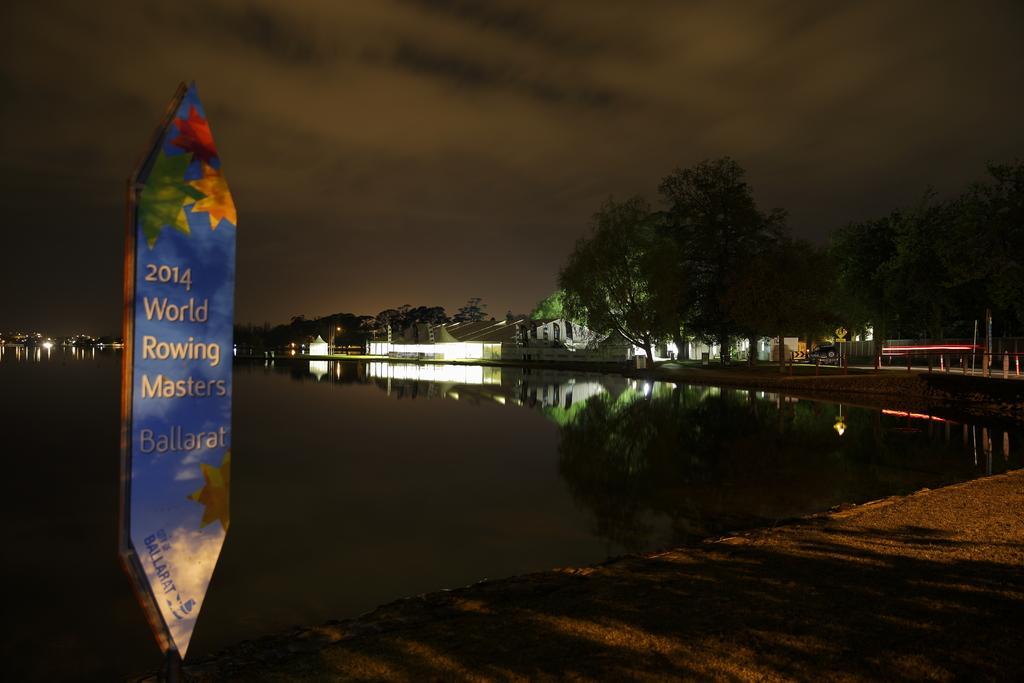In one or two sentences, can you explain what this image depicts? In this image I can see the ground, a board and the water. In the background I can see few buildings, few poles, few lights, a car on the road, few trees and the dark sky. 